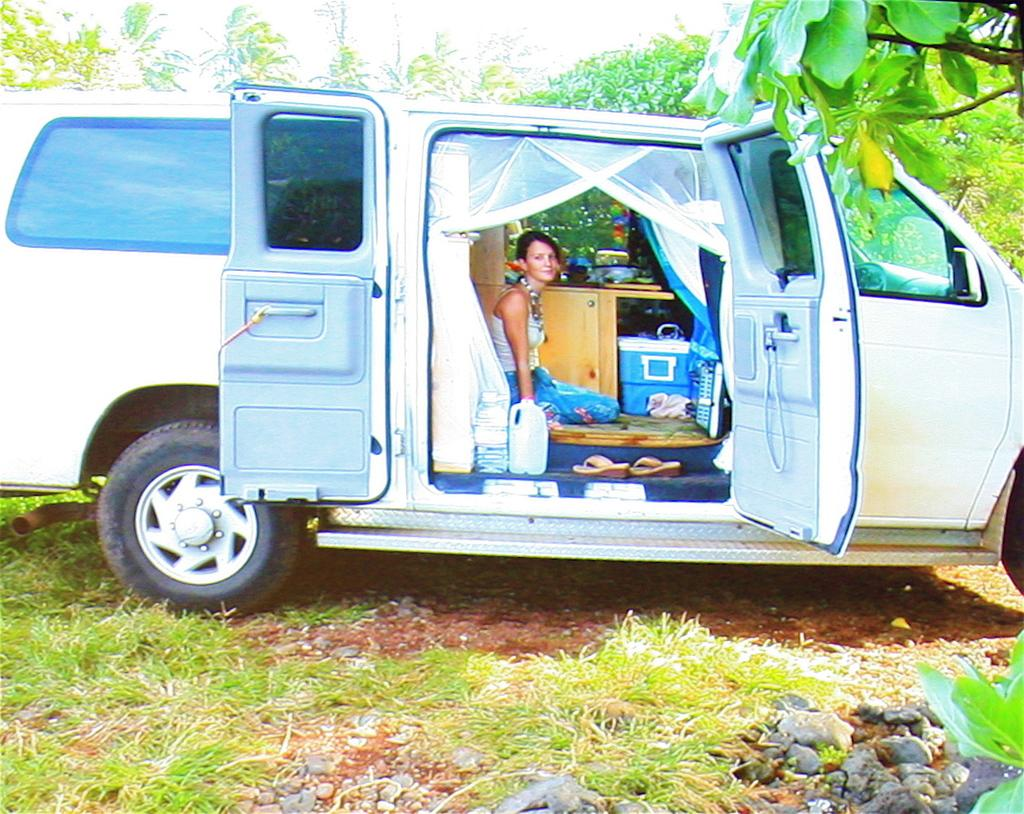Where was the image taken? The image is taken outdoors. What can be seen inside the car in the image? There is a woman sitting in a white car, a table, sandals, and other items in the car. What is the color of the car in the image? The car in the image is white. What is visible behind the car in the image? There are trees behind the car in the image. What type of throat-soothing remedy is present in the image? There is no throat-soothing remedy present in the image. What scent can be detected from the items in the car? The image does not provide information about the scent of the items in the car. 